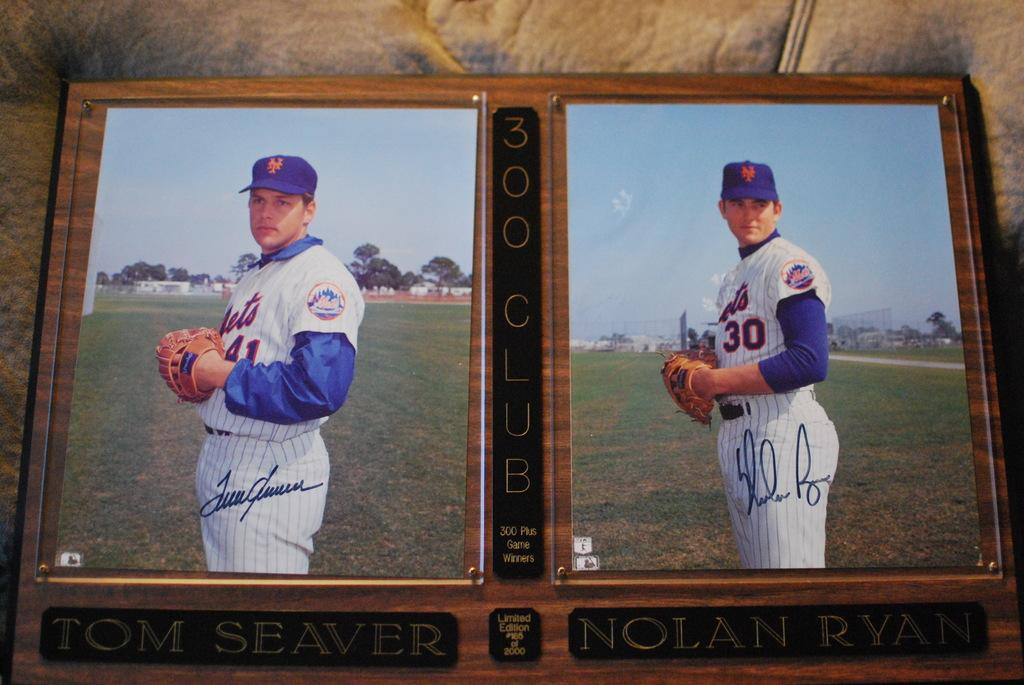<image>
Provide a brief description of the given image. NOLAN RYAN is a very famous baseball player. 